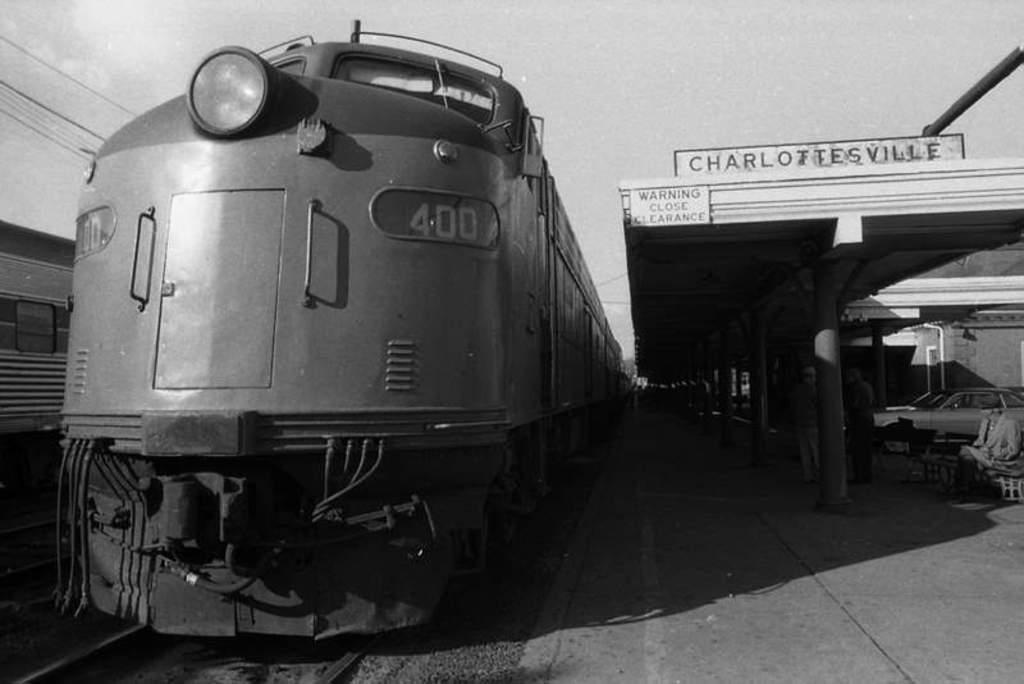Could you give a brief overview of what you see in this image? In the image we can see there are trains standing on the railway tracks and there is a platform. There are people standing on the platform and there are cars parked on the platform. There is a hoarding kept on the building of the platform and the sky is clear. The image is in black and white colour. 